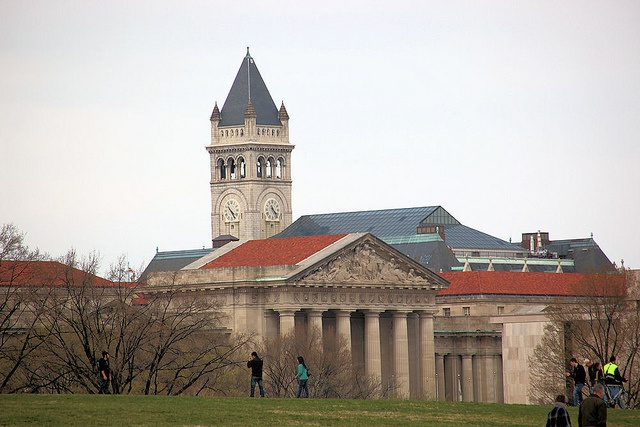Describe the objects in this image and their specific colors. I can see people in lightgray, black, gray, teal, and yellow tones, people in lightgray, black, maroon, and gray tones, people in lightgray, black, gray, darkgreen, and maroon tones, people in lightgray, black, gray, maroon, and darkblue tones, and people in lightgray, black, gray, and maroon tones in this image. 